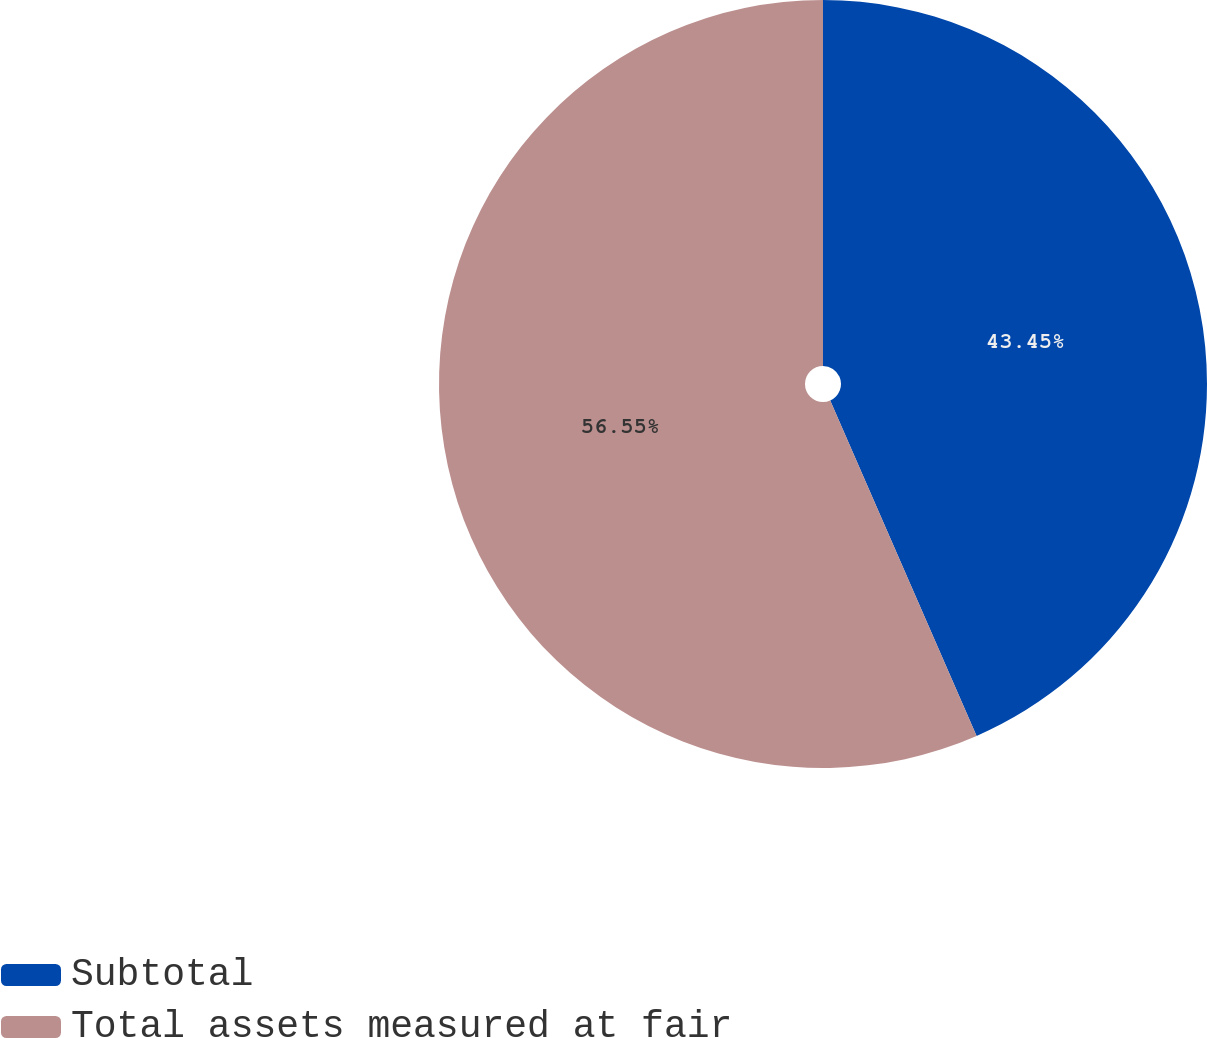Convert chart. <chart><loc_0><loc_0><loc_500><loc_500><pie_chart><fcel>Subtotal<fcel>Total assets measured at fair<nl><fcel>43.45%<fcel>56.55%<nl></chart> 